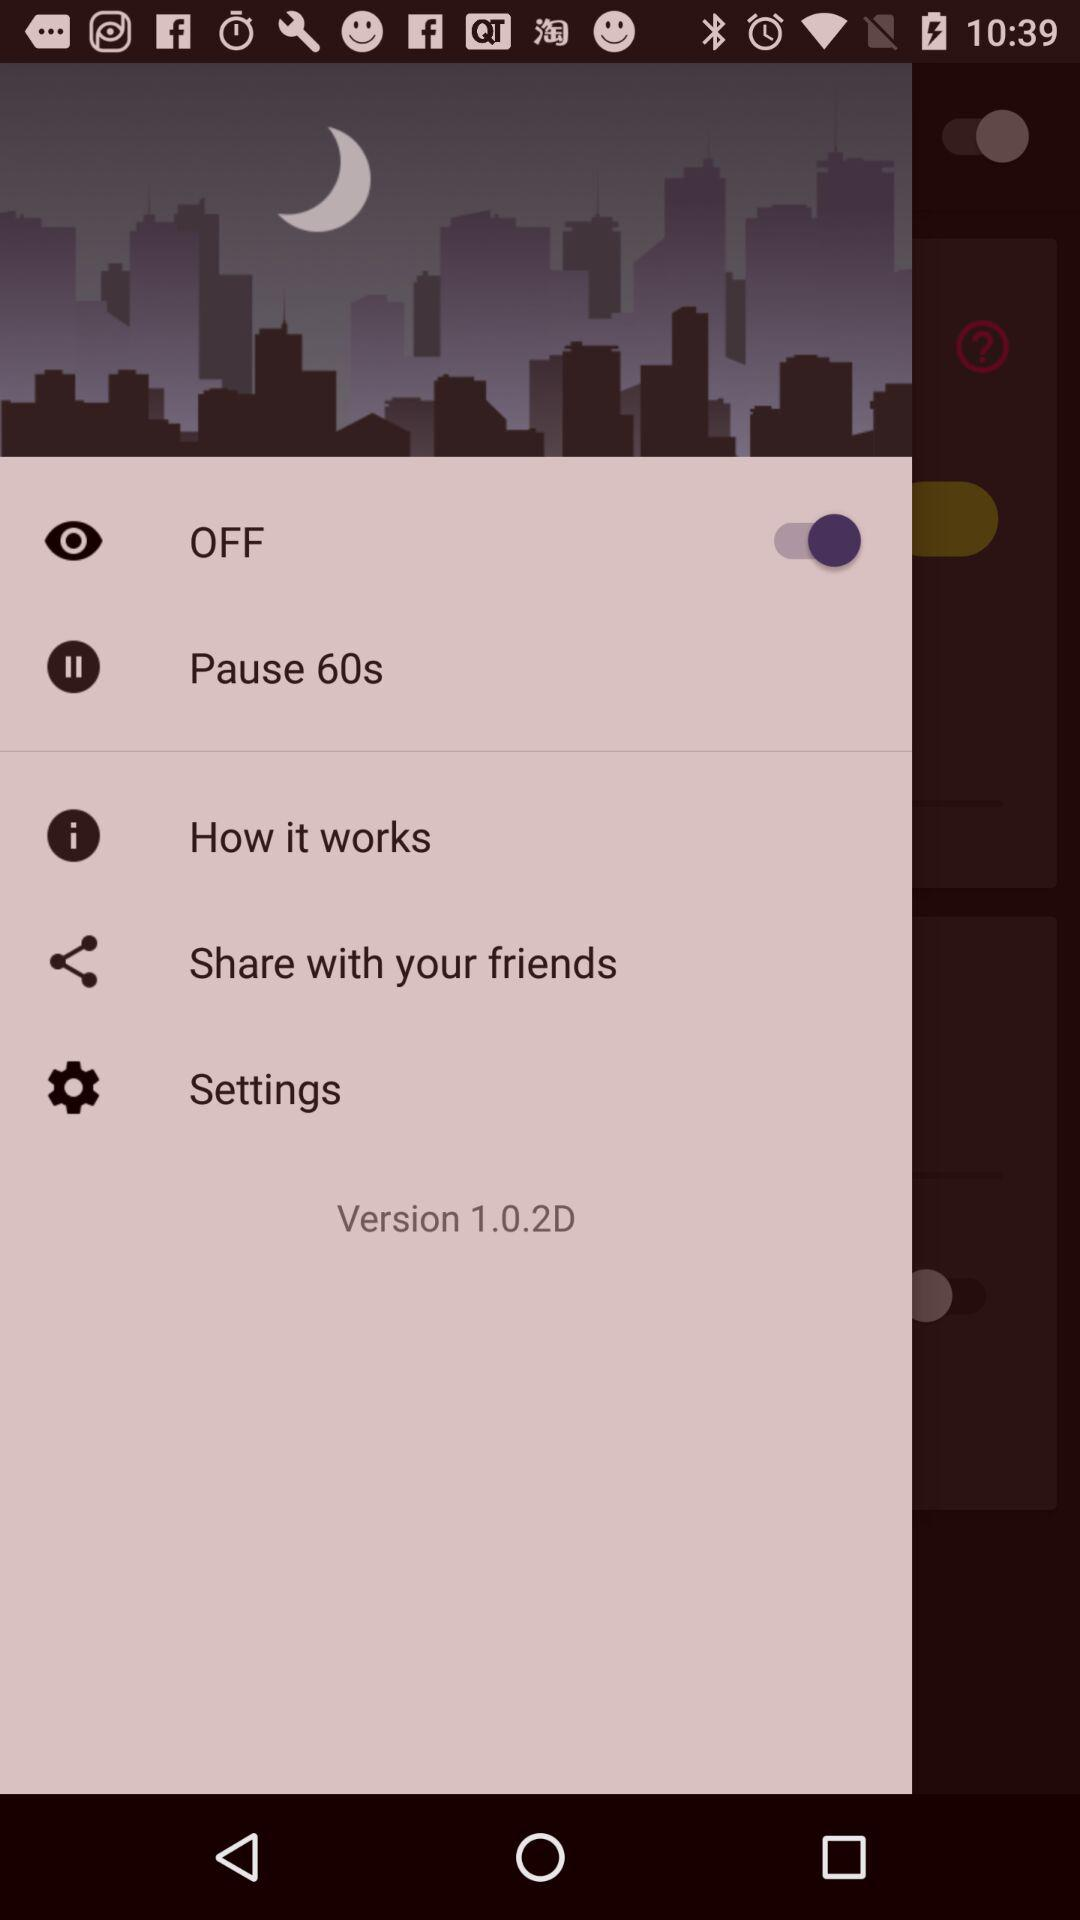What's the pause duration? The duration is "60 seconds". 